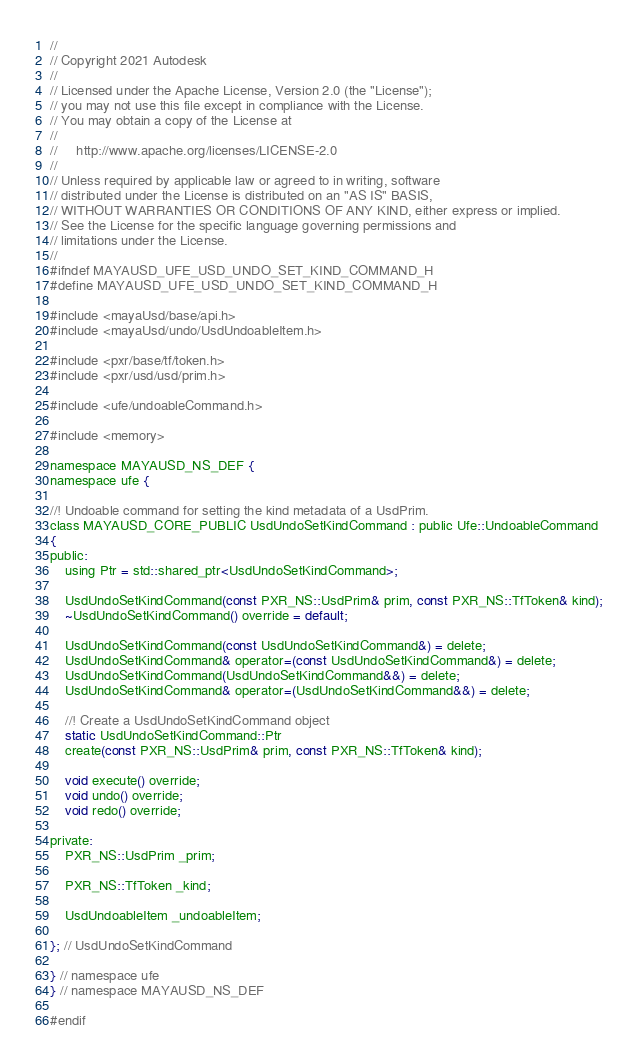<code> <loc_0><loc_0><loc_500><loc_500><_C_>//
// Copyright 2021 Autodesk
//
// Licensed under the Apache License, Version 2.0 (the "License");
// you may not use this file except in compliance with the License.
// You may obtain a copy of the License at
//
//     http://www.apache.org/licenses/LICENSE-2.0
//
// Unless required by applicable law or agreed to in writing, software
// distributed under the License is distributed on an "AS IS" BASIS,
// WITHOUT WARRANTIES OR CONDITIONS OF ANY KIND, either express or implied.
// See the License for the specific language governing permissions and
// limitations under the License.
//
#ifndef MAYAUSD_UFE_USD_UNDO_SET_KIND_COMMAND_H
#define MAYAUSD_UFE_USD_UNDO_SET_KIND_COMMAND_H

#include <mayaUsd/base/api.h>
#include <mayaUsd/undo/UsdUndoableItem.h>

#include <pxr/base/tf/token.h>
#include <pxr/usd/usd/prim.h>

#include <ufe/undoableCommand.h>

#include <memory>

namespace MAYAUSD_NS_DEF {
namespace ufe {

//! Undoable command for setting the kind metadata of a UsdPrim.
class MAYAUSD_CORE_PUBLIC UsdUndoSetKindCommand : public Ufe::UndoableCommand
{
public:
    using Ptr = std::shared_ptr<UsdUndoSetKindCommand>;

    UsdUndoSetKindCommand(const PXR_NS::UsdPrim& prim, const PXR_NS::TfToken& kind);
    ~UsdUndoSetKindCommand() override = default;

    UsdUndoSetKindCommand(const UsdUndoSetKindCommand&) = delete;
    UsdUndoSetKindCommand& operator=(const UsdUndoSetKindCommand&) = delete;
    UsdUndoSetKindCommand(UsdUndoSetKindCommand&&) = delete;
    UsdUndoSetKindCommand& operator=(UsdUndoSetKindCommand&&) = delete;

    //! Create a UsdUndoSetKindCommand object
    static UsdUndoSetKindCommand::Ptr
    create(const PXR_NS::UsdPrim& prim, const PXR_NS::TfToken& kind);

    void execute() override;
    void undo() override;
    void redo() override;

private:
    PXR_NS::UsdPrim _prim;

    PXR_NS::TfToken _kind;

    UsdUndoableItem _undoableItem;

}; // UsdUndoSetKindCommand

} // namespace ufe
} // namespace MAYAUSD_NS_DEF

#endif
</code> 